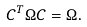Convert formula to latex. <formula><loc_0><loc_0><loc_500><loc_500>C ^ { T } \Omega C = \Omega .</formula> 